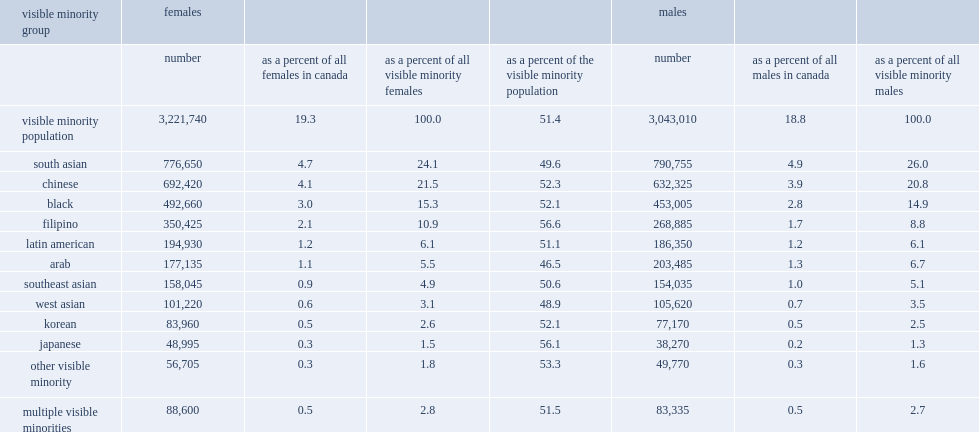In 2011, south asian was the largest visible minority group among both females and males for the first time, what was the percentage of female visible minorities? 24.1. In 2011, south asian was the largest visible minority group among both females and males for the first time, what was the percentag of male visible minorities? 26.0. What the percentage of females visible minorities were chinese in 2011? 21.5. What the percentage of males visible minorities were chinese in 2011? 20.8. What was the proportion of the filipino groups that were female was higher compared with canada's total female population, and the overall female visible minority population? 56.6. What was the proportion of the japanese groups that were female was higher compared with canada's total female population, and the overall female visible minority population? 56.1. What was the proportion of females in the arab groups compared with the same two reference populations? 46.5. What was the proportion of females in the west asian groups compared with the same two reference populations? 48.9. 